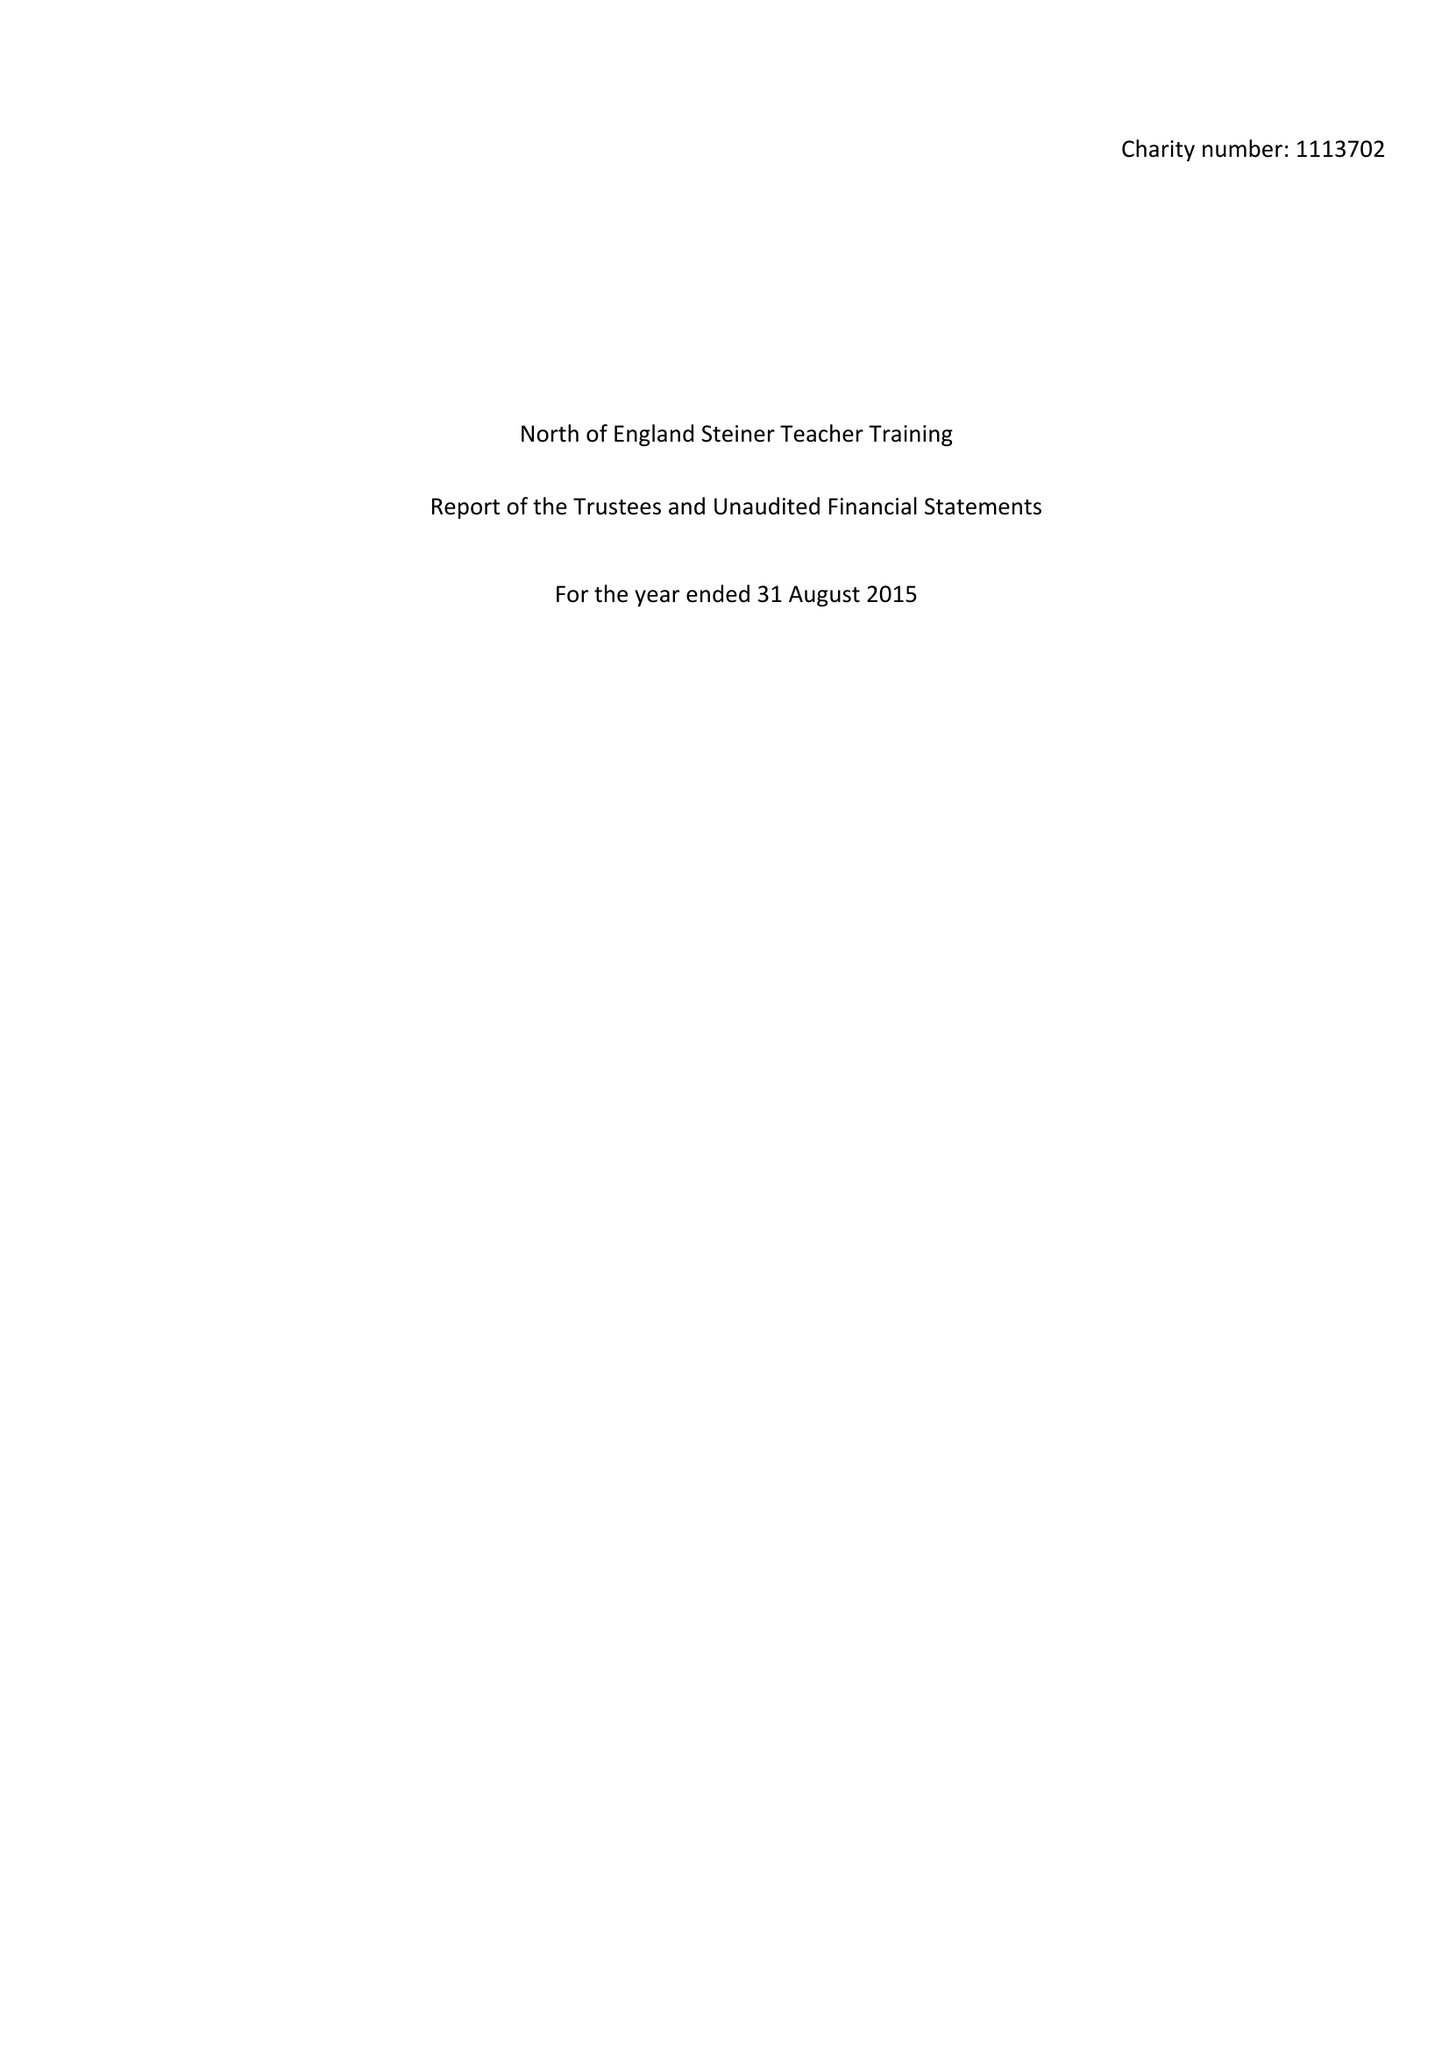What is the value for the charity_name?
Answer the question using a single word or phrase. North Of England Steiner Teacher Training 